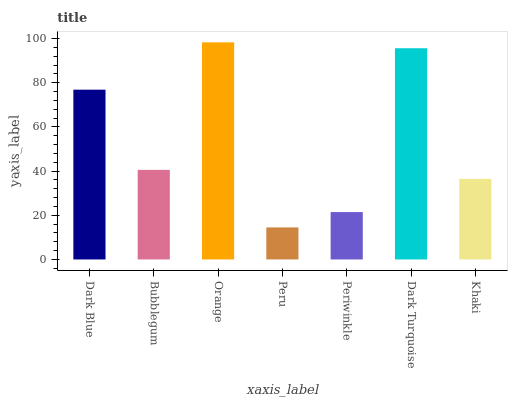Is Peru the minimum?
Answer yes or no. Yes. Is Orange the maximum?
Answer yes or no. Yes. Is Bubblegum the minimum?
Answer yes or no. No. Is Bubblegum the maximum?
Answer yes or no. No. Is Dark Blue greater than Bubblegum?
Answer yes or no. Yes. Is Bubblegum less than Dark Blue?
Answer yes or no. Yes. Is Bubblegum greater than Dark Blue?
Answer yes or no. No. Is Dark Blue less than Bubblegum?
Answer yes or no. No. Is Bubblegum the high median?
Answer yes or no. Yes. Is Bubblegum the low median?
Answer yes or no. Yes. Is Khaki the high median?
Answer yes or no. No. Is Dark Turquoise the low median?
Answer yes or no. No. 